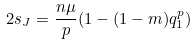<formula> <loc_0><loc_0><loc_500><loc_500>2 s _ { J } = \frac { n \mu } { p } ( 1 - ( 1 - m ) q ^ { p } _ { 1 } )</formula> 